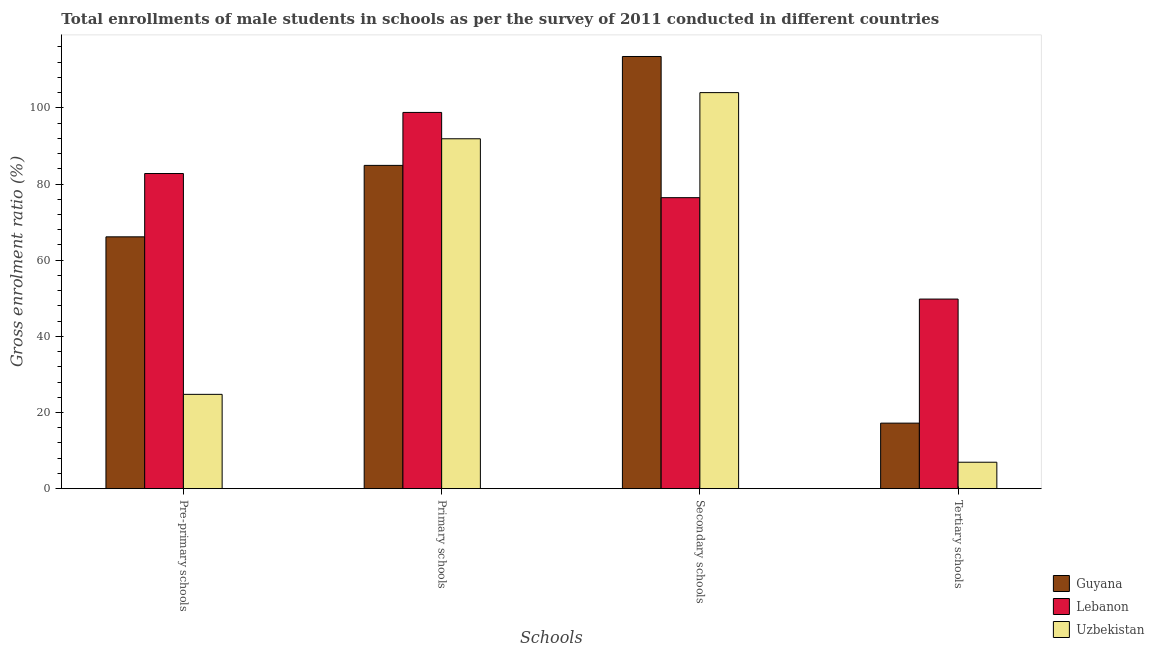How many different coloured bars are there?
Give a very brief answer. 3. Are the number of bars per tick equal to the number of legend labels?
Offer a very short reply. Yes. How many bars are there on the 3rd tick from the left?
Provide a succinct answer. 3. What is the label of the 3rd group of bars from the left?
Your response must be concise. Secondary schools. What is the gross enrolment ratio(male) in primary schools in Guyana?
Offer a terse response. 84.9. Across all countries, what is the maximum gross enrolment ratio(male) in pre-primary schools?
Keep it short and to the point. 82.76. Across all countries, what is the minimum gross enrolment ratio(male) in pre-primary schools?
Your answer should be very brief. 24.77. In which country was the gross enrolment ratio(male) in secondary schools maximum?
Make the answer very short. Guyana. In which country was the gross enrolment ratio(male) in secondary schools minimum?
Provide a succinct answer. Lebanon. What is the total gross enrolment ratio(male) in tertiary schools in the graph?
Provide a short and direct response. 73.95. What is the difference between the gross enrolment ratio(male) in secondary schools in Uzbekistan and that in Guyana?
Give a very brief answer. -9.49. What is the difference between the gross enrolment ratio(male) in primary schools in Uzbekistan and the gross enrolment ratio(male) in tertiary schools in Guyana?
Your response must be concise. 74.67. What is the average gross enrolment ratio(male) in pre-primary schools per country?
Keep it short and to the point. 57.89. What is the difference between the gross enrolment ratio(male) in pre-primary schools and gross enrolment ratio(male) in secondary schools in Lebanon?
Provide a succinct answer. 6.34. In how many countries, is the gross enrolment ratio(male) in secondary schools greater than 68 %?
Keep it short and to the point. 3. What is the ratio of the gross enrolment ratio(male) in secondary schools in Guyana to that in Uzbekistan?
Ensure brevity in your answer.  1.09. Is the gross enrolment ratio(male) in secondary schools in Lebanon less than that in Uzbekistan?
Provide a succinct answer. Yes. Is the difference between the gross enrolment ratio(male) in secondary schools in Uzbekistan and Lebanon greater than the difference between the gross enrolment ratio(male) in pre-primary schools in Uzbekistan and Lebanon?
Provide a succinct answer. Yes. What is the difference between the highest and the second highest gross enrolment ratio(male) in primary schools?
Provide a succinct answer. 6.92. What is the difference between the highest and the lowest gross enrolment ratio(male) in pre-primary schools?
Provide a succinct answer. 57.99. What does the 1st bar from the left in Pre-primary schools represents?
Your response must be concise. Guyana. What does the 2nd bar from the right in Tertiary schools represents?
Give a very brief answer. Lebanon. How many countries are there in the graph?
Ensure brevity in your answer.  3. What is the difference between two consecutive major ticks on the Y-axis?
Offer a very short reply. 20. Are the values on the major ticks of Y-axis written in scientific E-notation?
Give a very brief answer. No. Does the graph contain any zero values?
Make the answer very short. No. Does the graph contain grids?
Make the answer very short. No. Where does the legend appear in the graph?
Make the answer very short. Bottom right. What is the title of the graph?
Your answer should be compact. Total enrollments of male students in schools as per the survey of 2011 conducted in different countries. What is the label or title of the X-axis?
Ensure brevity in your answer.  Schools. What is the Gross enrolment ratio (%) in Guyana in Pre-primary schools?
Ensure brevity in your answer.  66.13. What is the Gross enrolment ratio (%) of Lebanon in Pre-primary schools?
Your answer should be very brief. 82.76. What is the Gross enrolment ratio (%) of Uzbekistan in Pre-primary schools?
Provide a succinct answer. 24.77. What is the Gross enrolment ratio (%) of Guyana in Primary schools?
Your response must be concise. 84.9. What is the Gross enrolment ratio (%) of Lebanon in Primary schools?
Offer a very short reply. 98.8. What is the Gross enrolment ratio (%) of Uzbekistan in Primary schools?
Ensure brevity in your answer.  91.88. What is the Gross enrolment ratio (%) in Guyana in Secondary schools?
Provide a succinct answer. 113.49. What is the Gross enrolment ratio (%) of Lebanon in Secondary schools?
Offer a very short reply. 76.42. What is the Gross enrolment ratio (%) of Uzbekistan in Secondary schools?
Ensure brevity in your answer.  104. What is the Gross enrolment ratio (%) of Guyana in Tertiary schools?
Provide a succinct answer. 17.21. What is the Gross enrolment ratio (%) in Lebanon in Tertiary schools?
Keep it short and to the point. 49.79. What is the Gross enrolment ratio (%) of Uzbekistan in Tertiary schools?
Give a very brief answer. 6.95. Across all Schools, what is the maximum Gross enrolment ratio (%) in Guyana?
Ensure brevity in your answer.  113.49. Across all Schools, what is the maximum Gross enrolment ratio (%) of Lebanon?
Offer a terse response. 98.8. Across all Schools, what is the maximum Gross enrolment ratio (%) in Uzbekistan?
Offer a very short reply. 104. Across all Schools, what is the minimum Gross enrolment ratio (%) in Guyana?
Keep it short and to the point. 17.21. Across all Schools, what is the minimum Gross enrolment ratio (%) in Lebanon?
Offer a terse response. 49.79. Across all Schools, what is the minimum Gross enrolment ratio (%) of Uzbekistan?
Your answer should be very brief. 6.95. What is the total Gross enrolment ratio (%) in Guyana in the graph?
Keep it short and to the point. 281.73. What is the total Gross enrolment ratio (%) in Lebanon in the graph?
Provide a succinct answer. 307.77. What is the total Gross enrolment ratio (%) in Uzbekistan in the graph?
Make the answer very short. 227.6. What is the difference between the Gross enrolment ratio (%) of Guyana in Pre-primary schools and that in Primary schools?
Offer a very short reply. -18.76. What is the difference between the Gross enrolment ratio (%) in Lebanon in Pre-primary schools and that in Primary schools?
Provide a succinct answer. -16.04. What is the difference between the Gross enrolment ratio (%) of Uzbekistan in Pre-primary schools and that in Primary schools?
Offer a terse response. -67.11. What is the difference between the Gross enrolment ratio (%) in Guyana in Pre-primary schools and that in Secondary schools?
Provide a succinct answer. -47.36. What is the difference between the Gross enrolment ratio (%) in Lebanon in Pre-primary schools and that in Secondary schools?
Offer a terse response. 6.34. What is the difference between the Gross enrolment ratio (%) of Uzbekistan in Pre-primary schools and that in Secondary schools?
Your answer should be very brief. -79.23. What is the difference between the Gross enrolment ratio (%) of Guyana in Pre-primary schools and that in Tertiary schools?
Offer a terse response. 48.92. What is the difference between the Gross enrolment ratio (%) of Lebanon in Pre-primary schools and that in Tertiary schools?
Keep it short and to the point. 32.97. What is the difference between the Gross enrolment ratio (%) in Uzbekistan in Pre-primary schools and that in Tertiary schools?
Make the answer very short. 17.82. What is the difference between the Gross enrolment ratio (%) in Guyana in Primary schools and that in Secondary schools?
Ensure brevity in your answer.  -28.59. What is the difference between the Gross enrolment ratio (%) of Lebanon in Primary schools and that in Secondary schools?
Your answer should be compact. 22.38. What is the difference between the Gross enrolment ratio (%) of Uzbekistan in Primary schools and that in Secondary schools?
Your answer should be compact. -12.12. What is the difference between the Gross enrolment ratio (%) of Guyana in Primary schools and that in Tertiary schools?
Give a very brief answer. 67.69. What is the difference between the Gross enrolment ratio (%) of Lebanon in Primary schools and that in Tertiary schools?
Provide a succinct answer. 49.01. What is the difference between the Gross enrolment ratio (%) of Uzbekistan in Primary schools and that in Tertiary schools?
Make the answer very short. 84.94. What is the difference between the Gross enrolment ratio (%) in Guyana in Secondary schools and that in Tertiary schools?
Ensure brevity in your answer.  96.28. What is the difference between the Gross enrolment ratio (%) of Lebanon in Secondary schools and that in Tertiary schools?
Your answer should be compact. 26.63. What is the difference between the Gross enrolment ratio (%) in Uzbekistan in Secondary schools and that in Tertiary schools?
Provide a short and direct response. 97.06. What is the difference between the Gross enrolment ratio (%) of Guyana in Pre-primary schools and the Gross enrolment ratio (%) of Lebanon in Primary schools?
Your answer should be compact. -32.67. What is the difference between the Gross enrolment ratio (%) in Guyana in Pre-primary schools and the Gross enrolment ratio (%) in Uzbekistan in Primary schools?
Provide a succinct answer. -25.75. What is the difference between the Gross enrolment ratio (%) in Lebanon in Pre-primary schools and the Gross enrolment ratio (%) in Uzbekistan in Primary schools?
Offer a very short reply. -9.12. What is the difference between the Gross enrolment ratio (%) of Guyana in Pre-primary schools and the Gross enrolment ratio (%) of Lebanon in Secondary schools?
Your answer should be compact. -10.28. What is the difference between the Gross enrolment ratio (%) in Guyana in Pre-primary schools and the Gross enrolment ratio (%) in Uzbekistan in Secondary schools?
Give a very brief answer. -37.87. What is the difference between the Gross enrolment ratio (%) of Lebanon in Pre-primary schools and the Gross enrolment ratio (%) of Uzbekistan in Secondary schools?
Offer a very short reply. -21.24. What is the difference between the Gross enrolment ratio (%) of Guyana in Pre-primary schools and the Gross enrolment ratio (%) of Lebanon in Tertiary schools?
Offer a terse response. 16.34. What is the difference between the Gross enrolment ratio (%) in Guyana in Pre-primary schools and the Gross enrolment ratio (%) in Uzbekistan in Tertiary schools?
Your answer should be very brief. 59.19. What is the difference between the Gross enrolment ratio (%) of Lebanon in Pre-primary schools and the Gross enrolment ratio (%) of Uzbekistan in Tertiary schools?
Offer a very short reply. 75.81. What is the difference between the Gross enrolment ratio (%) of Guyana in Primary schools and the Gross enrolment ratio (%) of Lebanon in Secondary schools?
Your response must be concise. 8.48. What is the difference between the Gross enrolment ratio (%) of Guyana in Primary schools and the Gross enrolment ratio (%) of Uzbekistan in Secondary schools?
Offer a very short reply. -19.11. What is the difference between the Gross enrolment ratio (%) in Lebanon in Primary schools and the Gross enrolment ratio (%) in Uzbekistan in Secondary schools?
Offer a very short reply. -5.2. What is the difference between the Gross enrolment ratio (%) of Guyana in Primary schools and the Gross enrolment ratio (%) of Lebanon in Tertiary schools?
Offer a terse response. 35.11. What is the difference between the Gross enrolment ratio (%) of Guyana in Primary schools and the Gross enrolment ratio (%) of Uzbekistan in Tertiary schools?
Ensure brevity in your answer.  77.95. What is the difference between the Gross enrolment ratio (%) of Lebanon in Primary schools and the Gross enrolment ratio (%) of Uzbekistan in Tertiary schools?
Offer a terse response. 91.85. What is the difference between the Gross enrolment ratio (%) of Guyana in Secondary schools and the Gross enrolment ratio (%) of Lebanon in Tertiary schools?
Offer a very short reply. 63.7. What is the difference between the Gross enrolment ratio (%) of Guyana in Secondary schools and the Gross enrolment ratio (%) of Uzbekistan in Tertiary schools?
Make the answer very short. 106.54. What is the difference between the Gross enrolment ratio (%) in Lebanon in Secondary schools and the Gross enrolment ratio (%) in Uzbekistan in Tertiary schools?
Provide a succinct answer. 69.47. What is the average Gross enrolment ratio (%) of Guyana per Schools?
Your answer should be very brief. 70.43. What is the average Gross enrolment ratio (%) in Lebanon per Schools?
Provide a succinct answer. 76.94. What is the average Gross enrolment ratio (%) of Uzbekistan per Schools?
Your answer should be very brief. 56.9. What is the difference between the Gross enrolment ratio (%) in Guyana and Gross enrolment ratio (%) in Lebanon in Pre-primary schools?
Your answer should be compact. -16.62. What is the difference between the Gross enrolment ratio (%) in Guyana and Gross enrolment ratio (%) in Uzbekistan in Pre-primary schools?
Provide a short and direct response. 41.37. What is the difference between the Gross enrolment ratio (%) in Lebanon and Gross enrolment ratio (%) in Uzbekistan in Pre-primary schools?
Provide a succinct answer. 57.99. What is the difference between the Gross enrolment ratio (%) in Guyana and Gross enrolment ratio (%) in Lebanon in Primary schools?
Your answer should be compact. -13.9. What is the difference between the Gross enrolment ratio (%) in Guyana and Gross enrolment ratio (%) in Uzbekistan in Primary schools?
Make the answer very short. -6.99. What is the difference between the Gross enrolment ratio (%) in Lebanon and Gross enrolment ratio (%) in Uzbekistan in Primary schools?
Offer a terse response. 6.92. What is the difference between the Gross enrolment ratio (%) in Guyana and Gross enrolment ratio (%) in Lebanon in Secondary schools?
Make the answer very short. 37.07. What is the difference between the Gross enrolment ratio (%) in Guyana and Gross enrolment ratio (%) in Uzbekistan in Secondary schools?
Your answer should be very brief. 9.49. What is the difference between the Gross enrolment ratio (%) of Lebanon and Gross enrolment ratio (%) of Uzbekistan in Secondary schools?
Make the answer very short. -27.59. What is the difference between the Gross enrolment ratio (%) of Guyana and Gross enrolment ratio (%) of Lebanon in Tertiary schools?
Your answer should be compact. -32.58. What is the difference between the Gross enrolment ratio (%) of Guyana and Gross enrolment ratio (%) of Uzbekistan in Tertiary schools?
Your response must be concise. 10.26. What is the difference between the Gross enrolment ratio (%) of Lebanon and Gross enrolment ratio (%) of Uzbekistan in Tertiary schools?
Offer a terse response. 42.84. What is the ratio of the Gross enrolment ratio (%) of Guyana in Pre-primary schools to that in Primary schools?
Your answer should be very brief. 0.78. What is the ratio of the Gross enrolment ratio (%) of Lebanon in Pre-primary schools to that in Primary schools?
Provide a short and direct response. 0.84. What is the ratio of the Gross enrolment ratio (%) in Uzbekistan in Pre-primary schools to that in Primary schools?
Provide a succinct answer. 0.27. What is the ratio of the Gross enrolment ratio (%) of Guyana in Pre-primary schools to that in Secondary schools?
Ensure brevity in your answer.  0.58. What is the ratio of the Gross enrolment ratio (%) in Lebanon in Pre-primary schools to that in Secondary schools?
Keep it short and to the point. 1.08. What is the ratio of the Gross enrolment ratio (%) of Uzbekistan in Pre-primary schools to that in Secondary schools?
Your answer should be compact. 0.24. What is the ratio of the Gross enrolment ratio (%) in Guyana in Pre-primary schools to that in Tertiary schools?
Ensure brevity in your answer.  3.84. What is the ratio of the Gross enrolment ratio (%) of Lebanon in Pre-primary schools to that in Tertiary schools?
Your response must be concise. 1.66. What is the ratio of the Gross enrolment ratio (%) of Uzbekistan in Pre-primary schools to that in Tertiary schools?
Ensure brevity in your answer.  3.57. What is the ratio of the Gross enrolment ratio (%) in Guyana in Primary schools to that in Secondary schools?
Your answer should be compact. 0.75. What is the ratio of the Gross enrolment ratio (%) in Lebanon in Primary schools to that in Secondary schools?
Offer a terse response. 1.29. What is the ratio of the Gross enrolment ratio (%) in Uzbekistan in Primary schools to that in Secondary schools?
Provide a short and direct response. 0.88. What is the ratio of the Gross enrolment ratio (%) of Guyana in Primary schools to that in Tertiary schools?
Offer a terse response. 4.93. What is the ratio of the Gross enrolment ratio (%) in Lebanon in Primary schools to that in Tertiary schools?
Your answer should be very brief. 1.98. What is the ratio of the Gross enrolment ratio (%) of Uzbekistan in Primary schools to that in Tertiary schools?
Your answer should be very brief. 13.23. What is the ratio of the Gross enrolment ratio (%) of Guyana in Secondary schools to that in Tertiary schools?
Offer a very short reply. 6.59. What is the ratio of the Gross enrolment ratio (%) in Lebanon in Secondary schools to that in Tertiary schools?
Keep it short and to the point. 1.53. What is the ratio of the Gross enrolment ratio (%) of Uzbekistan in Secondary schools to that in Tertiary schools?
Your answer should be compact. 14.97. What is the difference between the highest and the second highest Gross enrolment ratio (%) of Guyana?
Your answer should be compact. 28.59. What is the difference between the highest and the second highest Gross enrolment ratio (%) of Lebanon?
Keep it short and to the point. 16.04. What is the difference between the highest and the second highest Gross enrolment ratio (%) of Uzbekistan?
Make the answer very short. 12.12. What is the difference between the highest and the lowest Gross enrolment ratio (%) in Guyana?
Make the answer very short. 96.28. What is the difference between the highest and the lowest Gross enrolment ratio (%) of Lebanon?
Ensure brevity in your answer.  49.01. What is the difference between the highest and the lowest Gross enrolment ratio (%) in Uzbekistan?
Provide a succinct answer. 97.06. 